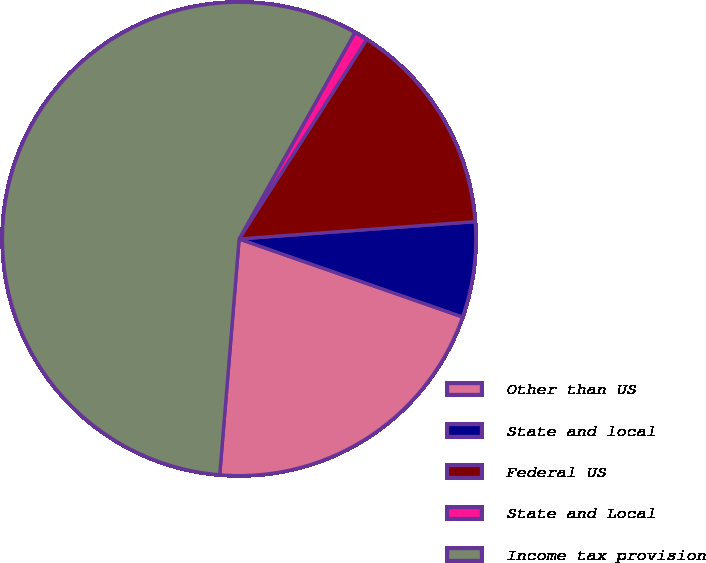Convert chart. <chart><loc_0><loc_0><loc_500><loc_500><pie_chart><fcel>Other than US<fcel>State and local<fcel>Federal US<fcel>State and Local<fcel>Income tax provision<nl><fcel>20.96%<fcel>6.51%<fcel>14.78%<fcel>0.92%<fcel>56.83%<nl></chart> 